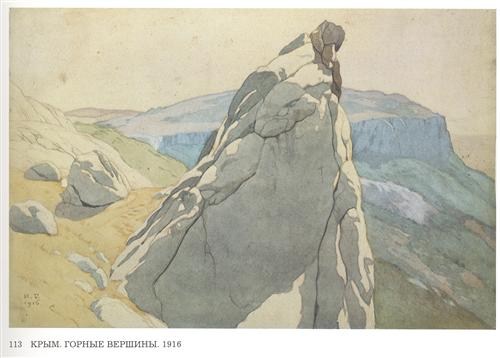Describe the mood and atmosphere conveyed by this painting. The painting exudes a peaceful and serene mood, achieved through the use of muted colors and the depiction of a calm, natural landscape. The towering rocky cliff in the foreground stands in quiet contrast to the soft, distant mountains, creating a balanced composition that invites viewers to immerse themselves in the tranquil beauty of nature. What artistic techniques can be observed in this painting? This painting showcases several artistic techniques characteristic of watercolor works from the early 20th century. Notice the use of light washes to create soft gradients and the subtle blending of colors for a naturalistic effect. The artist also employs precise line work to define the rocky cliff, which adds texture and depth. Furthermore, careful layering creates a sense of atmospheric perspective, helping to convey the vastness of the Crimean Mountains. Imagine this scene during a thunderstorm. How would the painting change? If this scene were depicted during a thunderstorm, the atmosphere would shift dramatically. The muted colors might be replaced with darker, more intense hues to represent storm clouds. The serene mood would give way to one of tension and drama, with sharp, jagged strokes illustrating lightning and rain. The formerly soft, peaceful background would transform into a turbulent and dynamic storm-scape, capturing the raw power of nature. 